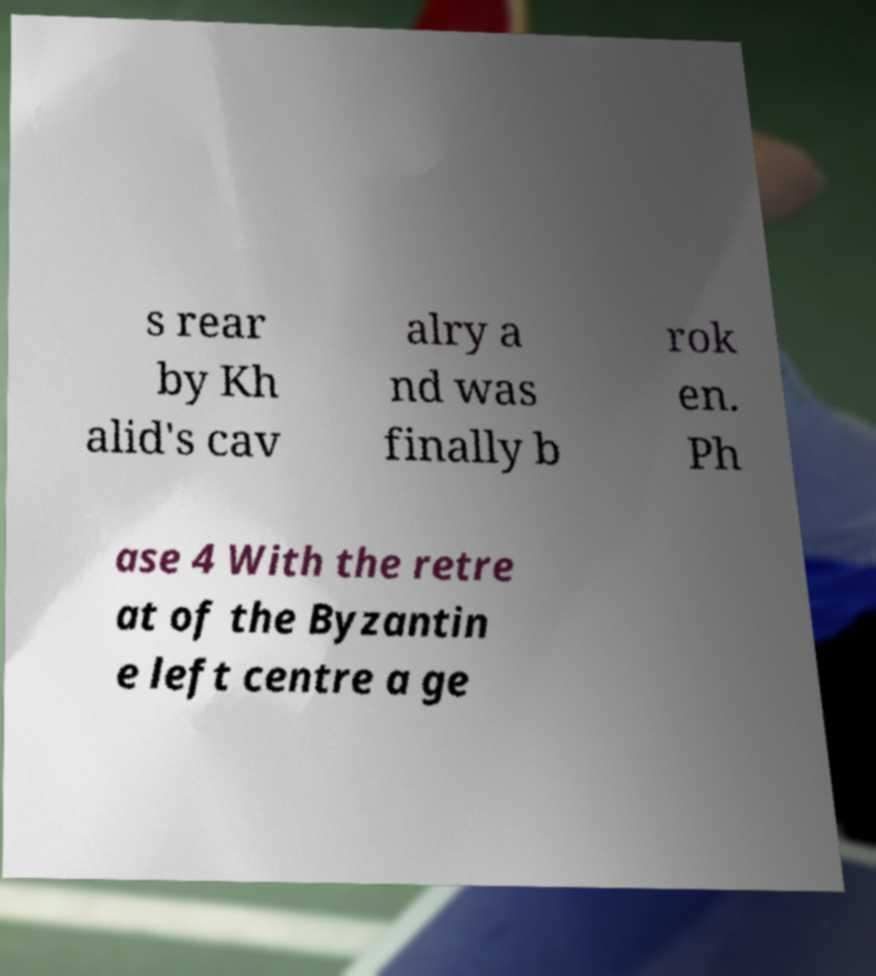There's text embedded in this image that I need extracted. Can you transcribe it verbatim? s rear by Kh alid's cav alry a nd was finally b rok en. Ph ase 4 With the retre at of the Byzantin e left centre a ge 